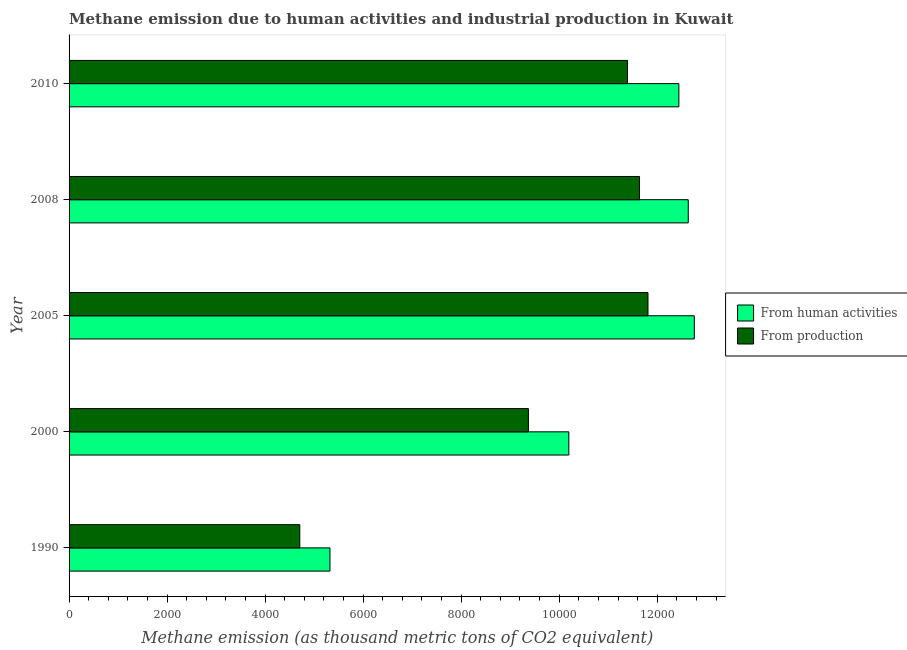How many groups of bars are there?
Your response must be concise. 5. Are the number of bars on each tick of the Y-axis equal?
Your answer should be compact. Yes. What is the label of the 3rd group of bars from the top?
Provide a succinct answer. 2005. In how many cases, is the number of bars for a given year not equal to the number of legend labels?
Ensure brevity in your answer.  0. What is the amount of emissions from human activities in 2008?
Offer a very short reply. 1.26e+04. Across all years, what is the maximum amount of emissions generated from industries?
Ensure brevity in your answer.  1.18e+04. Across all years, what is the minimum amount of emissions from human activities?
Your answer should be very brief. 5323.1. What is the total amount of emissions from human activities in the graph?
Give a very brief answer. 5.34e+04. What is the difference between the amount of emissions generated from industries in 2000 and that in 2005?
Provide a short and direct response. -2439.7. What is the difference between the amount of emissions generated from industries in 2000 and the amount of emissions from human activities in 1990?
Give a very brief answer. 4048.9. What is the average amount of emissions generated from industries per year?
Your response must be concise. 9784.84. In the year 2000, what is the difference between the amount of emissions from human activities and amount of emissions generated from industries?
Keep it short and to the point. 824.8. What is the ratio of the amount of emissions generated from industries in 2005 to that in 2010?
Provide a short and direct response. 1.04. Is the amount of emissions from human activities in 2008 less than that in 2010?
Ensure brevity in your answer.  No. What is the difference between the highest and the second highest amount of emissions from human activities?
Keep it short and to the point. 123.7. What is the difference between the highest and the lowest amount of emissions generated from industries?
Provide a short and direct response. 7104.2. Is the sum of the amount of emissions from human activities in 2000 and 2008 greater than the maximum amount of emissions generated from industries across all years?
Your response must be concise. Yes. What does the 2nd bar from the top in 2010 represents?
Offer a very short reply. From human activities. What does the 1st bar from the bottom in 2000 represents?
Make the answer very short. From human activities. Are all the bars in the graph horizontal?
Keep it short and to the point. Yes. How many years are there in the graph?
Your response must be concise. 5. Does the graph contain any zero values?
Give a very brief answer. No. Does the graph contain grids?
Offer a very short reply. No. How many legend labels are there?
Make the answer very short. 2. How are the legend labels stacked?
Offer a very short reply. Vertical. What is the title of the graph?
Ensure brevity in your answer.  Methane emission due to human activities and industrial production in Kuwait. What is the label or title of the X-axis?
Offer a very short reply. Methane emission (as thousand metric tons of CO2 equivalent). What is the label or title of the Y-axis?
Provide a short and direct response. Year. What is the Methane emission (as thousand metric tons of CO2 equivalent) of From human activities in 1990?
Keep it short and to the point. 5323.1. What is the Methane emission (as thousand metric tons of CO2 equivalent) of From production in 1990?
Provide a succinct answer. 4707.5. What is the Methane emission (as thousand metric tons of CO2 equivalent) in From human activities in 2000?
Your answer should be very brief. 1.02e+04. What is the Methane emission (as thousand metric tons of CO2 equivalent) of From production in 2000?
Provide a succinct answer. 9372. What is the Methane emission (as thousand metric tons of CO2 equivalent) of From human activities in 2005?
Provide a short and direct response. 1.28e+04. What is the Methane emission (as thousand metric tons of CO2 equivalent) of From production in 2005?
Your response must be concise. 1.18e+04. What is the Methane emission (as thousand metric tons of CO2 equivalent) in From human activities in 2008?
Your answer should be very brief. 1.26e+04. What is the Methane emission (as thousand metric tons of CO2 equivalent) in From production in 2008?
Offer a very short reply. 1.16e+04. What is the Methane emission (as thousand metric tons of CO2 equivalent) of From human activities in 2010?
Your answer should be compact. 1.24e+04. What is the Methane emission (as thousand metric tons of CO2 equivalent) in From production in 2010?
Offer a very short reply. 1.14e+04. Across all years, what is the maximum Methane emission (as thousand metric tons of CO2 equivalent) in From human activities?
Ensure brevity in your answer.  1.28e+04. Across all years, what is the maximum Methane emission (as thousand metric tons of CO2 equivalent) in From production?
Your response must be concise. 1.18e+04. Across all years, what is the minimum Methane emission (as thousand metric tons of CO2 equivalent) of From human activities?
Give a very brief answer. 5323.1. Across all years, what is the minimum Methane emission (as thousand metric tons of CO2 equivalent) of From production?
Provide a short and direct response. 4707.5. What is the total Methane emission (as thousand metric tons of CO2 equivalent) of From human activities in the graph?
Provide a short and direct response. 5.34e+04. What is the total Methane emission (as thousand metric tons of CO2 equivalent) in From production in the graph?
Ensure brevity in your answer.  4.89e+04. What is the difference between the Methane emission (as thousand metric tons of CO2 equivalent) in From human activities in 1990 and that in 2000?
Provide a short and direct response. -4873.7. What is the difference between the Methane emission (as thousand metric tons of CO2 equivalent) of From production in 1990 and that in 2000?
Keep it short and to the point. -4664.5. What is the difference between the Methane emission (as thousand metric tons of CO2 equivalent) of From human activities in 1990 and that in 2005?
Make the answer very short. -7433.7. What is the difference between the Methane emission (as thousand metric tons of CO2 equivalent) in From production in 1990 and that in 2005?
Give a very brief answer. -7104.2. What is the difference between the Methane emission (as thousand metric tons of CO2 equivalent) of From human activities in 1990 and that in 2008?
Keep it short and to the point. -7310. What is the difference between the Methane emission (as thousand metric tons of CO2 equivalent) in From production in 1990 and that in 2008?
Keep it short and to the point. -6931.3. What is the difference between the Methane emission (as thousand metric tons of CO2 equivalent) of From human activities in 1990 and that in 2010?
Your answer should be very brief. -7118.6. What is the difference between the Methane emission (as thousand metric tons of CO2 equivalent) of From production in 1990 and that in 2010?
Keep it short and to the point. -6686.7. What is the difference between the Methane emission (as thousand metric tons of CO2 equivalent) of From human activities in 2000 and that in 2005?
Provide a short and direct response. -2560. What is the difference between the Methane emission (as thousand metric tons of CO2 equivalent) in From production in 2000 and that in 2005?
Make the answer very short. -2439.7. What is the difference between the Methane emission (as thousand metric tons of CO2 equivalent) of From human activities in 2000 and that in 2008?
Your answer should be very brief. -2436.3. What is the difference between the Methane emission (as thousand metric tons of CO2 equivalent) of From production in 2000 and that in 2008?
Offer a terse response. -2266.8. What is the difference between the Methane emission (as thousand metric tons of CO2 equivalent) of From human activities in 2000 and that in 2010?
Ensure brevity in your answer.  -2244.9. What is the difference between the Methane emission (as thousand metric tons of CO2 equivalent) in From production in 2000 and that in 2010?
Give a very brief answer. -2022.2. What is the difference between the Methane emission (as thousand metric tons of CO2 equivalent) of From human activities in 2005 and that in 2008?
Your answer should be compact. 123.7. What is the difference between the Methane emission (as thousand metric tons of CO2 equivalent) of From production in 2005 and that in 2008?
Keep it short and to the point. 172.9. What is the difference between the Methane emission (as thousand metric tons of CO2 equivalent) in From human activities in 2005 and that in 2010?
Your answer should be compact. 315.1. What is the difference between the Methane emission (as thousand metric tons of CO2 equivalent) in From production in 2005 and that in 2010?
Ensure brevity in your answer.  417.5. What is the difference between the Methane emission (as thousand metric tons of CO2 equivalent) in From human activities in 2008 and that in 2010?
Keep it short and to the point. 191.4. What is the difference between the Methane emission (as thousand metric tons of CO2 equivalent) of From production in 2008 and that in 2010?
Make the answer very short. 244.6. What is the difference between the Methane emission (as thousand metric tons of CO2 equivalent) in From human activities in 1990 and the Methane emission (as thousand metric tons of CO2 equivalent) in From production in 2000?
Offer a very short reply. -4048.9. What is the difference between the Methane emission (as thousand metric tons of CO2 equivalent) in From human activities in 1990 and the Methane emission (as thousand metric tons of CO2 equivalent) in From production in 2005?
Your answer should be very brief. -6488.6. What is the difference between the Methane emission (as thousand metric tons of CO2 equivalent) in From human activities in 1990 and the Methane emission (as thousand metric tons of CO2 equivalent) in From production in 2008?
Provide a succinct answer. -6315.7. What is the difference between the Methane emission (as thousand metric tons of CO2 equivalent) in From human activities in 1990 and the Methane emission (as thousand metric tons of CO2 equivalent) in From production in 2010?
Give a very brief answer. -6071.1. What is the difference between the Methane emission (as thousand metric tons of CO2 equivalent) of From human activities in 2000 and the Methane emission (as thousand metric tons of CO2 equivalent) of From production in 2005?
Your response must be concise. -1614.9. What is the difference between the Methane emission (as thousand metric tons of CO2 equivalent) of From human activities in 2000 and the Methane emission (as thousand metric tons of CO2 equivalent) of From production in 2008?
Your answer should be very brief. -1442. What is the difference between the Methane emission (as thousand metric tons of CO2 equivalent) in From human activities in 2000 and the Methane emission (as thousand metric tons of CO2 equivalent) in From production in 2010?
Offer a terse response. -1197.4. What is the difference between the Methane emission (as thousand metric tons of CO2 equivalent) in From human activities in 2005 and the Methane emission (as thousand metric tons of CO2 equivalent) in From production in 2008?
Give a very brief answer. 1118. What is the difference between the Methane emission (as thousand metric tons of CO2 equivalent) in From human activities in 2005 and the Methane emission (as thousand metric tons of CO2 equivalent) in From production in 2010?
Your answer should be very brief. 1362.6. What is the difference between the Methane emission (as thousand metric tons of CO2 equivalent) in From human activities in 2008 and the Methane emission (as thousand metric tons of CO2 equivalent) in From production in 2010?
Your answer should be compact. 1238.9. What is the average Methane emission (as thousand metric tons of CO2 equivalent) in From human activities per year?
Your response must be concise. 1.07e+04. What is the average Methane emission (as thousand metric tons of CO2 equivalent) of From production per year?
Offer a terse response. 9784.84. In the year 1990, what is the difference between the Methane emission (as thousand metric tons of CO2 equivalent) of From human activities and Methane emission (as thousand metric tons of CO2 equivalent) of From production?
Your answer should be very brief. 615.6. In the year 2000, what is the difference between the Methane emission (as thousand metric tons of CO2 equivalent) of From human activities and Methane emission (as thousand metric tons of CO2 equivalent) of From production?
Your answer should be very brief. 824.8. In the year 2005, what is the difference between the Methane emission (as thousand metric tons of CO2 equivalent) of From human activities and Methane emission (as thousand metric tons of CO2 equivalent) of From production?
Your answer should be compact. 945.1. In the year 2008, what is the difference between the Methane emission (as thousand metric tons of CO2 equivalent) of From human activities and Methane emission (as thousand metric tons of CO2 equivalent) of From production?
Offer a very short reply. 994.3. In the year 2010, what is the difference between the Methane emission (as thousand metric tons of CO2 equivalent) of From human activities and Methane emission (as thousand metric tons of CO2 equivalent) of From production?
Ensure brevity in your answer.  1047.5. What is the ratio of the Methane emission (as thousand metric tons of CO2 equivalent) in From human activities in 1990 to that in 2000?
Give a very brief answer. 0.52. What is the ratio of the Methane emission (as thousand metric tons of CO2 equivalent) in From production in 1990 to that in 2000?
Your answer should be very brief. 0.5. What is the ratio of the Methane emission (as thousand metric tons of CO2 equivalent) of From human activities in 1990 to that in 2005?
Ensure brevity in your answer.  0.42. What is the ratio of the Methane emission (as thousand metric tons of CO2 equivalent) of From production in 1990 to that in 2005?
Your response must be concise. 0.4. What is the ratio of the Methane emission (as thousand metric tons of CO2 equivalent) of From human activities in 1990 to that in 2008?
Make the answer very short. 0.42. What is the ratio of the Methane emission (as thousand metric tons of CO2 equivalent) of From production in 1990 to that in 2008?
Keep it short and to the point. 0.4. What is the ratio of the Methane emission (as thousand metric tons of CO2 equivalent) of From human activities in 1990 to that in 2010?
Make the answer very short. 0.43. What is the ratio of the Methane emission (as thousand metric tons of CO2 equivalent) in From production in 1990 to that in 2010?
Provide a succinct answer. 0.41. What is the ratio of the Methane emission (as thousand metric tons of CO2 equivalent) in From human activities in 2000 to that in 2005?
Ensure brevity in your answer.  0.8. What is the ratio of the Methane emission (as thousand metric tons of CO2 equivalent) of From production in 2000 to that in 2005?
Offer a terse response. 0.79. What is the ratio of the Methane emission (as thousand metric tons of CO2 equivalent) in From human activities in 2000 to that in 2008?
Provide a succinct answer. 0.81. What is the ratio of the Methane emission (as thousand metric tons of CO2 equivalent) of From production in 2000 to that in 2008?
Offer a very short reply. 0.81. What is the ratio of the Methane emission (as thousand metric tons of CO2 equivalent) in From human activities in 2000 to that in 2010?
Your answer should be compact. 0.82. What is the ratio of the Methane emission (as thousand metric tons of CO2 equivalent) in From production in 2000 to that in 2010?
Offer a very short reply. 0.82. What is the ratio of the Methane emission (as thousand metric tons of CO2 equivalent) of From human activities in 2005 to that in 2008?
Provide a succinct answer. 1.01. What is the ratio of the Methane emission (as thousand metric tons of CO2 equivalent) of From production in 2005 to that in 2008?
Provide a short and direct response. 1.01. What is the ratio of the Methane emission (as thousand metric tons of CO2 equivalent) of From human activities in 2005 to that in 2010?
Make the answer very short. 1.03. What is the ratio of the Methane emission (as thousand metric tons of CO2 equivalent) in From production in 2005 to that in 2010?
Your answer should be very brief. 1.04. What is the ratio of the Methane emission (as thousand metric tons of CO2 equivalent) of From human activities in 2008 to that in 2010?
Offer a terse response. 1.02. What is the ratio of the Methane emission (as thousand metric tons of CO2 equivalent) of From production in 2008 to that in 2010?
Provide a short and direct response. 1.02. What is the difference between the highest and the second highest Methane emission (as thousand metric tons of CO2 equivalent) of From human activities?
Offer a very short reply. 123.7. What is the difference between the highest and the second highest Methane emission (as thousand metric tons of CO2 equivalent) in From production?
Provide a succinct answer. 172.9. What is the difference between the highest and the lowest Methane emission (as thousand metric tons of CO2 equivalent) in From human activities?
Your answer should be very brief. 7433.7. What is the difference between the highest and the lowest Methane emission (as thousand metric tons of CO2 equivalent) of From production?
Your answer should be very brief. 7104.2. 